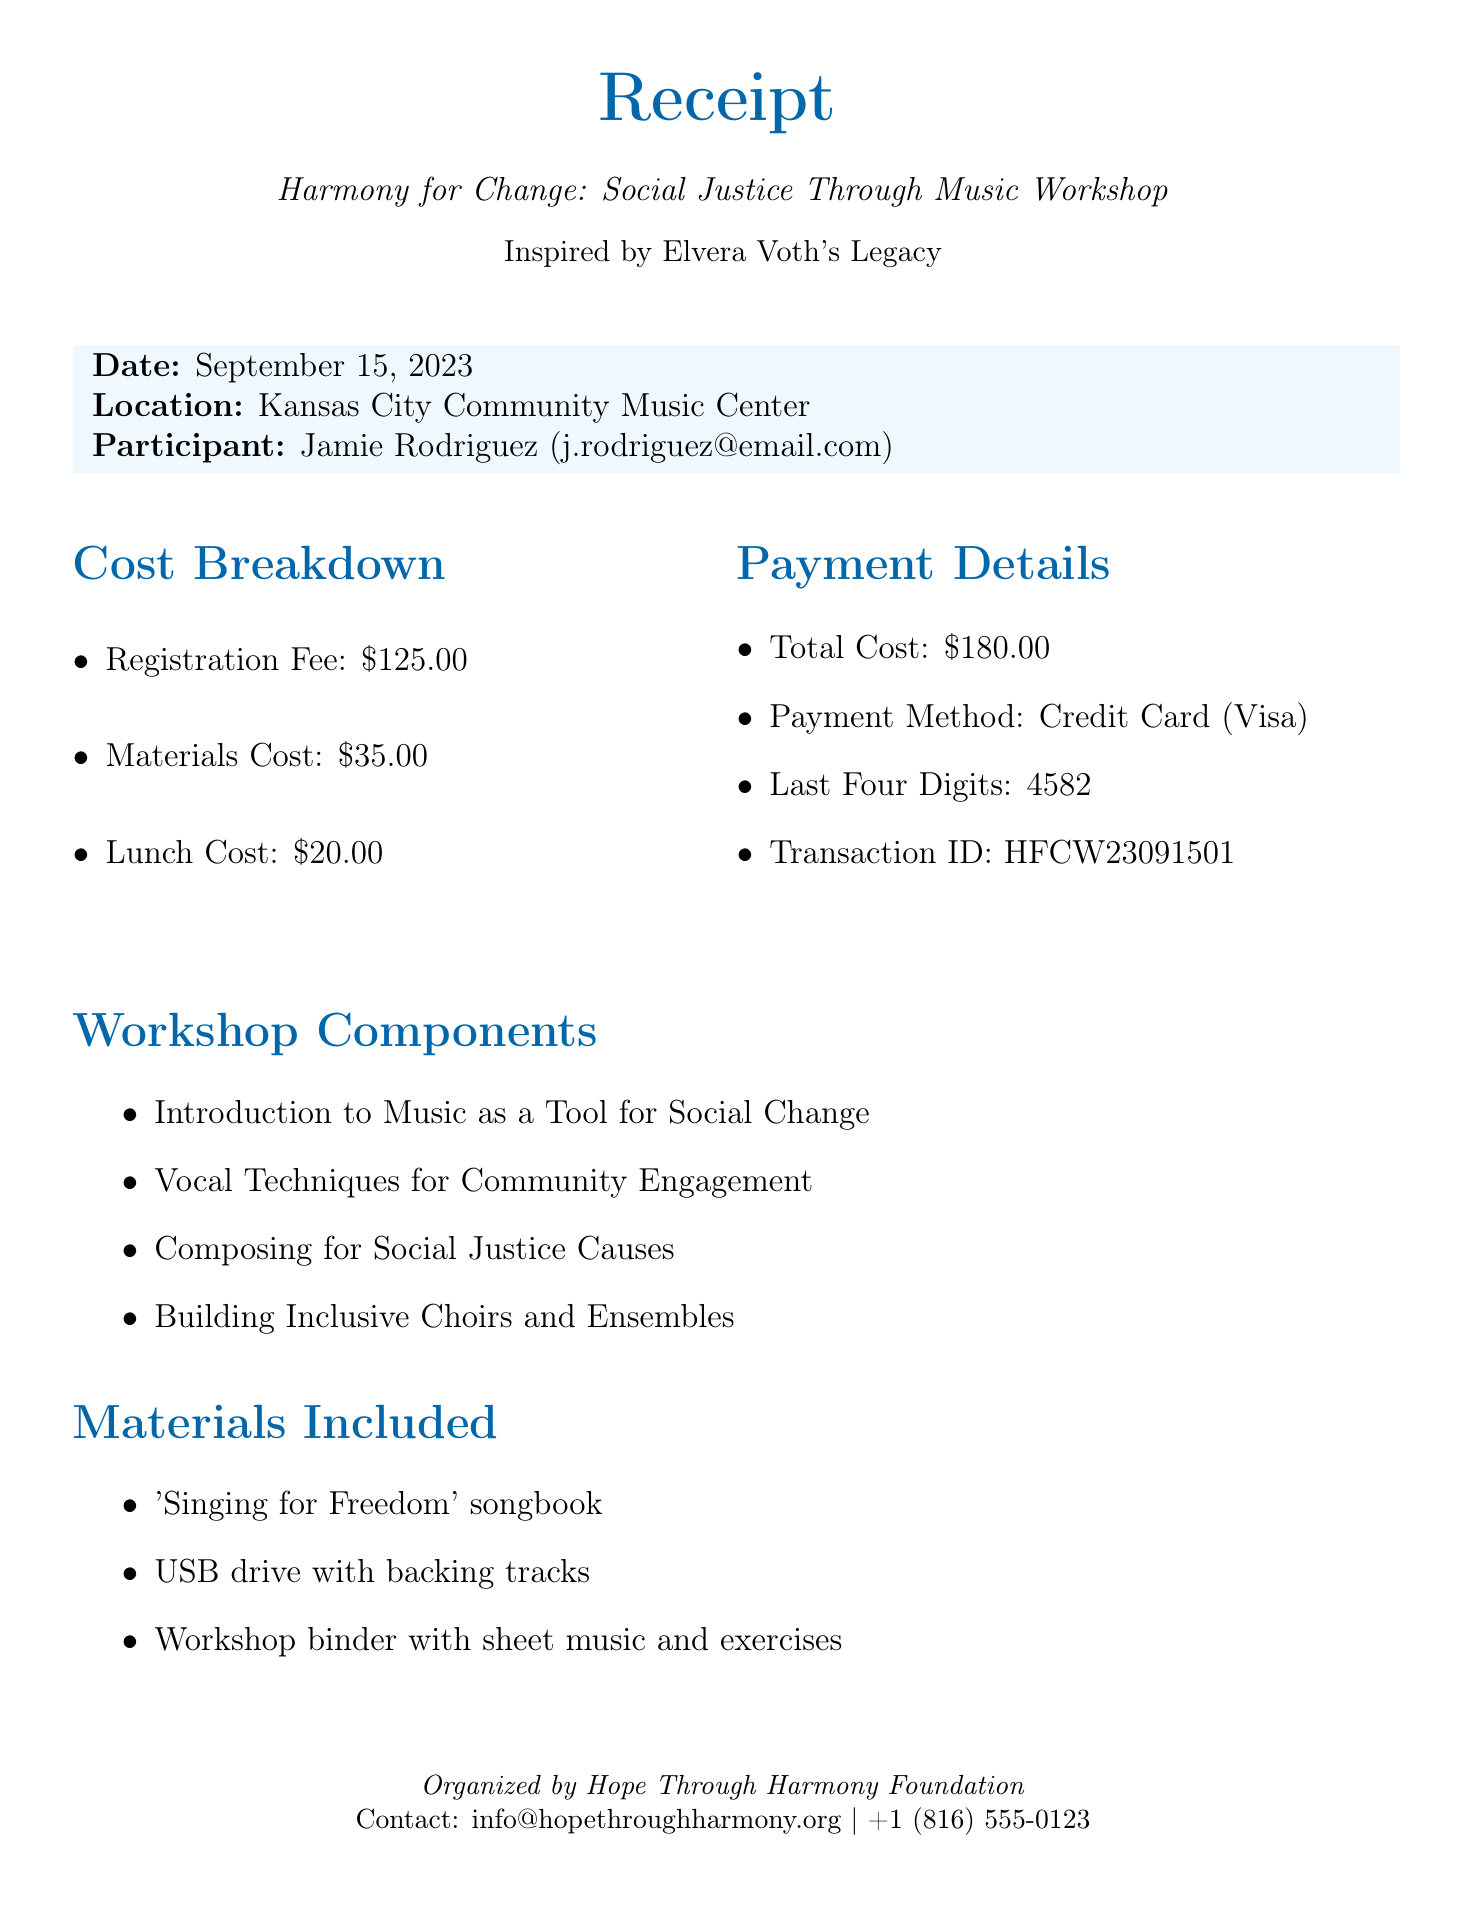what is the event name? The event name is the title given to the workshop, which is clearly stated in the document.
Answer: Harmony for Change: Social Justice Through Music Workshop who is the participant? The participant's name is provided in the document.
Answer: Jamie Rodriguez what is the registration fee? The registration fee is explicitly listed as one of the costs in the receipt.
Answer: $125.00 when is the workshop date? The date of the workshop is specified in the receipt.
Answer: September 15, 2023 how much is the total cost? The total cost is the sum of all individual costs provided in the document.
Answer: $180.00 what materials are included? The included materials are listed in a section dedicated to them in the document.
Answer: 'Singing for Freedom' songbook, USB drive with backing tracks, Workshop binder with sheet music and exercises what type of lunch options are available? The lunch menu lists the options available for participants.
Answer: Vegetarian and vegan options who organized the workshop? The organizer of the workshop is mentioned at the bottom of the document.
Answer: Hope Through Harmony Foundation what payment method was used? The payment method is specified under the payment details section in the document.
Answer: Credit Card (Visa) 